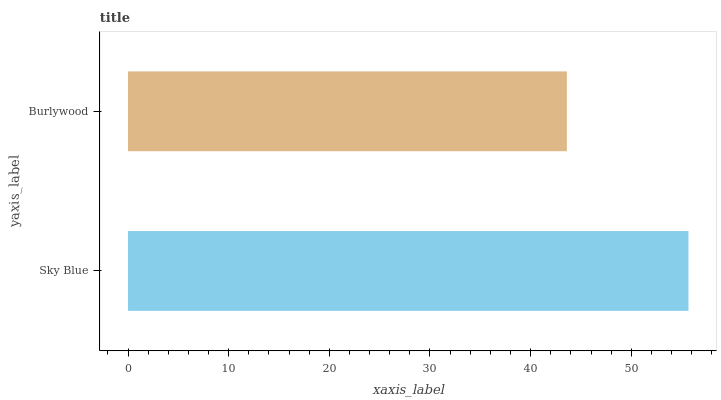Is Burlywood the minimum?
Answer yes or no. Yes. Is Sky Blue the maximum?
Answer yes or no. Yes. Is Burlywood the maximum?
Answer yes or no. No. Is Sky Blue greater than Burlywood?
Answer yes or no. Yes. Is Burlywood less than Sky Blue?
Answer yes or no. Yes. Is Burlywood greater than Sky Blue?
Answer yes or no. No. Is Sky Blue less than Burlywood?
Answer yes or no. No. Is Sky Blue the high median?
Answer yes or no. Yes. Is Burlywood the low median?
Answer yes or no. Yes. Is Burlywood the high median?
Answer yes or no. No. Is Sky Blue the low median?
Answer yes or no. No. 